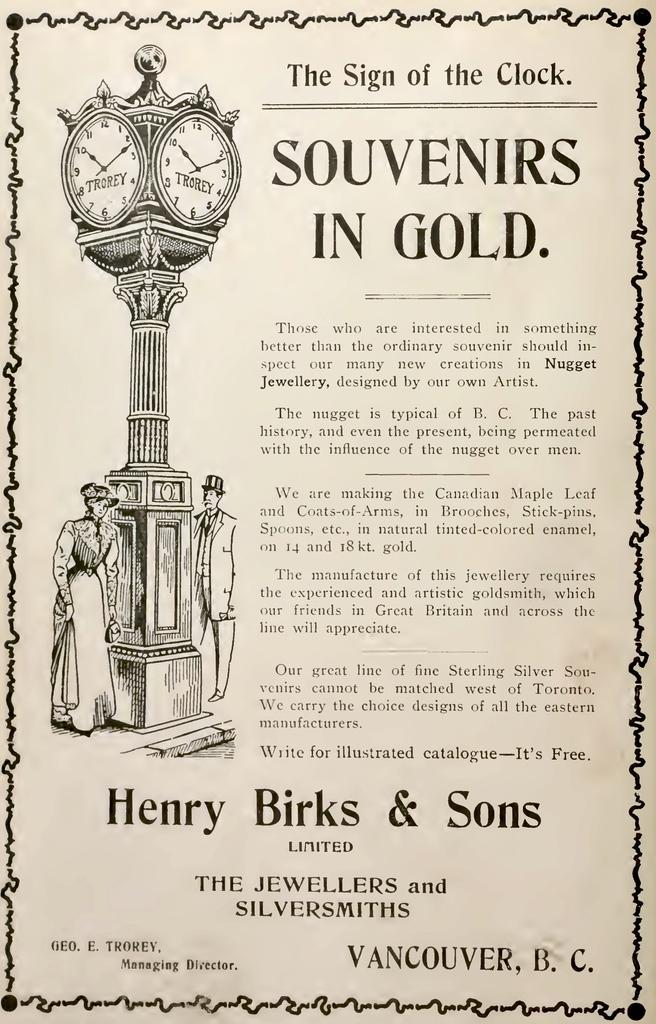What is depicted on the paper or poster in the image? There is a sketch of a man and a woman on a paper or poster in the image. What other objects can be seen in the image? There is a pole and clocks in the image. Where is the text located in the image? The text is written on the right side of the image. What type of sun can be seen in the image? There is no sun present in the image. What experience does the man have with the woman in the image? The image is a sketch, so it does not depict any actual experiences between the man and the woman. 